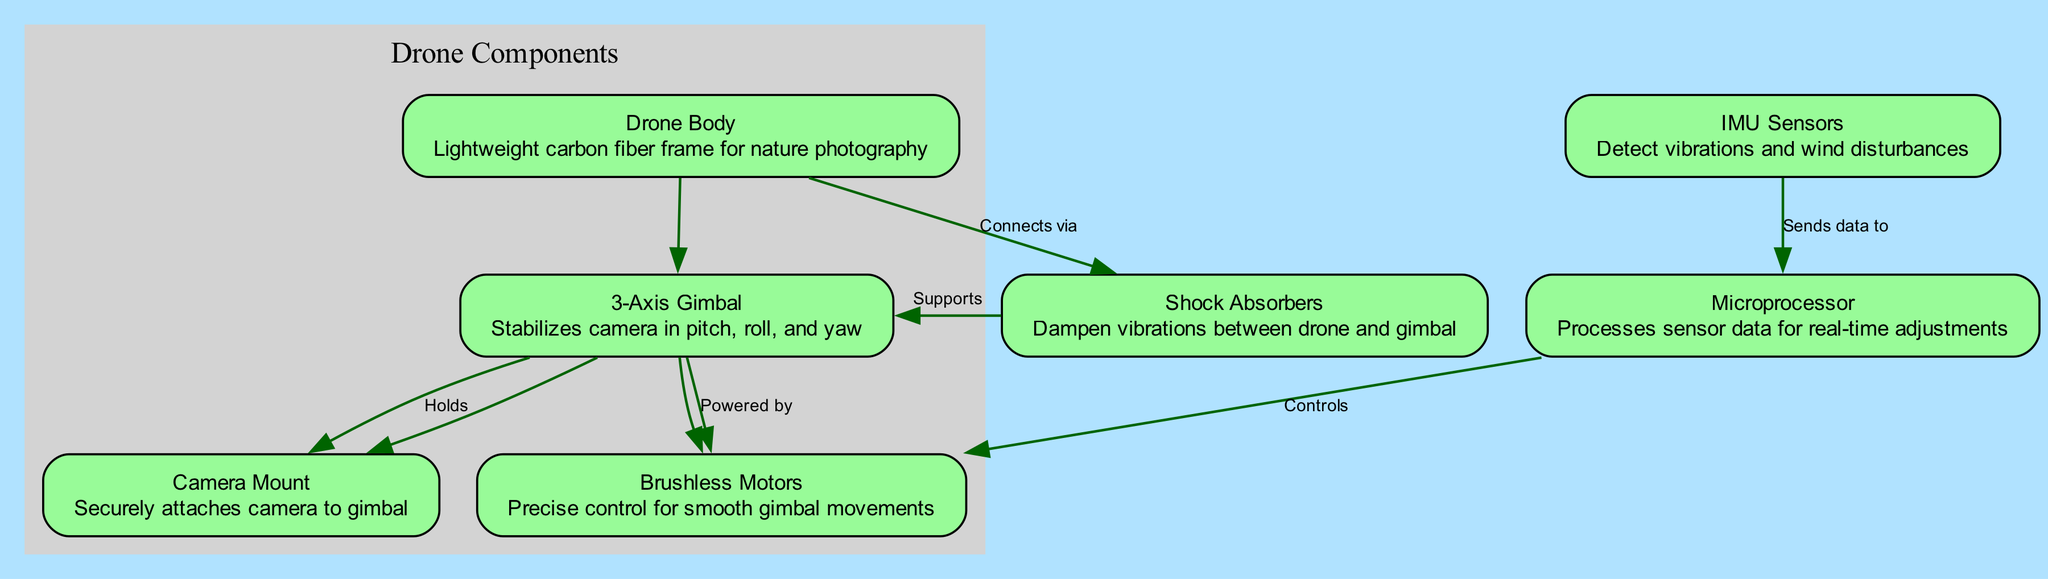What is the primary function of the 3-Axis Gimbal? The 3-Axis Gimbal stabilizes the camera in pitch, roll, and yaw, which helps to achieve stable aerial shots. This is a direct interpretation of the node's description in the diagram.
Answer: Stabilizes camera in pitch, roll, and yaw How many nodes are present in the diagram? Counting all the distinct components listed under nodes, there are seven identified elements, which are the Drone Body, 3-Axis Gimbal, Brushless Motors, IMU Sensors, Microprocessor, Shock Absorbers, and Camera Mount.
Answer: Seven Which component connects directly to the Drone Body? The Shock Absorbers are linked directly to the Drone Body, as indicated in the edges that connect node 1 to node 6.
Answer: Shock Absorbers What does the IMU Sensors send data to? The IMU Sensors send data directly to the Microprocessor, as mentioned in the edge connecting those two nodes. This is a straightforward relationship marked in the diagram.
Answer: Microprocessor How does the Microprocessor influence the Brushless Motors? The Microprocessor controls the Brushless Motors, which is shown in the edge connecting these two components, indicating that the sensor data processed by the Microprocessor directly impacts how the Brushless Motors operate for movement stabilization.
Answer: Controls What connects the Shock Absorbers and the 3-Axis Gimbal? The Shock Absorbers support the 3-Axis Gimbal, as indicated by the edge that connects these two nodes. This illustrates the role of the Shock Absorbers in stabilizing the gimbal system.
Answer: Supports How many edges connect the nodes in the diagram? Upon reviewing the edges connecting the various components, there are six distinct edges that facilitate the relationships among the nodes described in the diagram.
Answer: Six Which component holds the camera? The Camera Mount is designed to securely attach the camera to the 3-Axis Gimbal, as specified in the corresponding node description and the edge connecting these two elements.
Answer: Camera Mount 